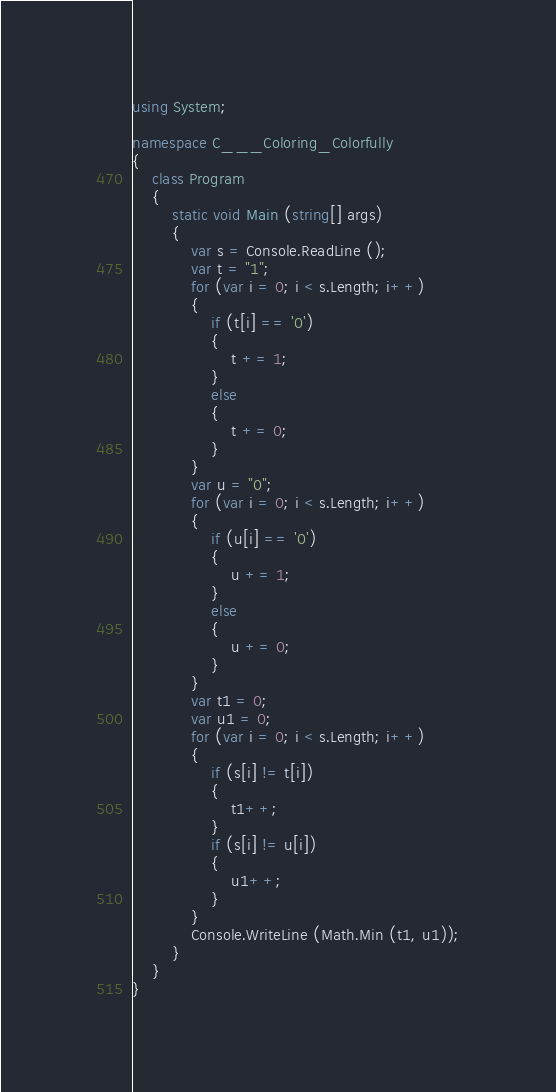<code> <loc_0><loc_0><loc_500><loc_500><_C#_>using System;

namespace C___Coloring_Colorfully
{
    class Program
    {
        static void Main (string[] args)
        {
            var s = Console.ReadLine ();
            var t = "1";
            for (var i = 0; i < s.Length; i++)
            {
                if (t[i] == '0')
                {
                    t += 1;
                }
                else
                {
                    t += 0;
                }
            }
            var u = "0";
            for (var i = 0; i < s.Length; i++)
            {
                if (u[i] == '0')
                {
                    u += 1;
                }
                else
                {
                    u += 0;
                }
            }
            var t1 = 0;
            var u1 = 0;
            for (var i = 0; i < s.Length; i++)
            {
                if (s[i] != t[i])
                {
                    t1++;
                }
                if (s[i] != u[i])
                {
                    u1++;
                }
            }
            Console.WriteLine (Math.Min (t1, u1));
        }
    }
}</code> 